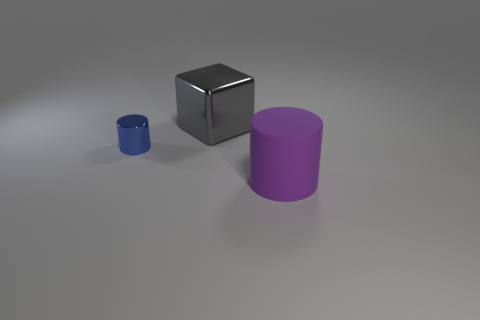Add 3 metal things. How many metal things are left? 5 Add 2 large purple rubber objects. How many large purple rubber objects exist? 3 Add 3 large purple matte cylinders. How many objects exist? 6 Subtract 0 blue balls. How many objects are left? 3 Subtract all cylinders. How many objects are left? 1 Subtract 1 cylinders. How many cylinders are left? 1 Subtract all yellow cylinders. Subtract all green blocks. How many cylinders are left? 2 Subtract all red cylinders. How many cyan cubes are left? 0 Subtract all big metal things. Subtract all green balls. How many objects are left? 2 